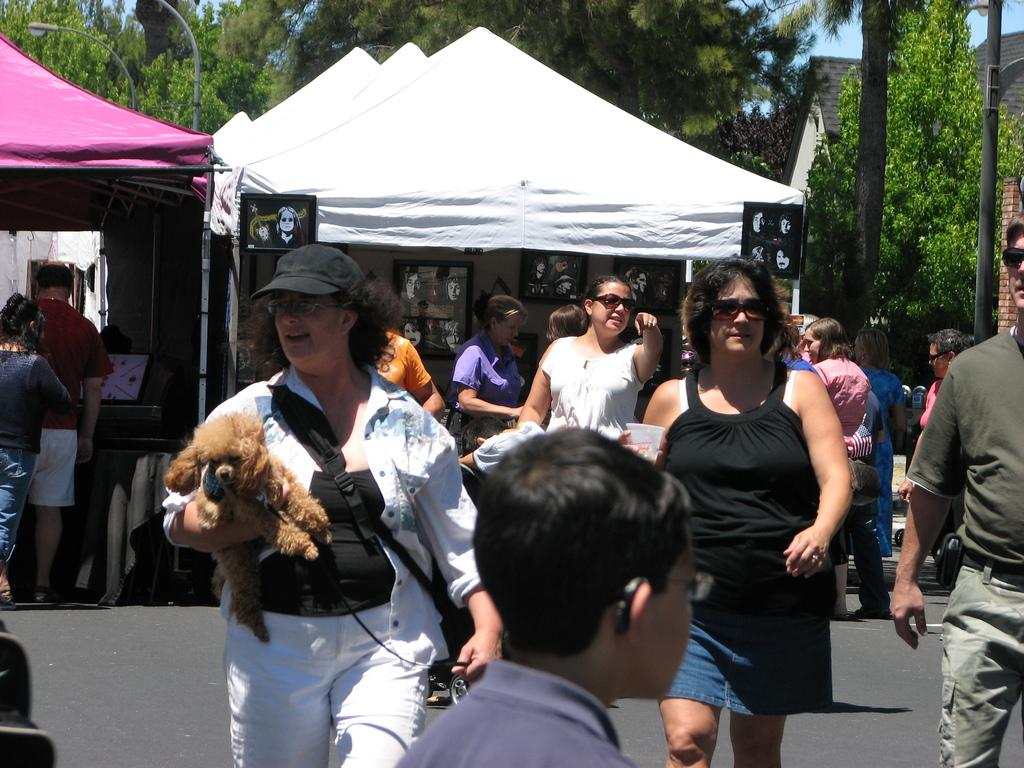What are the women in the image doing? The women in the image are walking. Can you describe the woman holding a dog and a bag? The woman holding a dog and a bag is wearing a black cap. What can be seen in the background of the image? In the background of the image, there are shops, trees, and houses. What is the maid saying good-bye to the woman with the dog and bag? There is no maid or good-bye in the image; it only shows women walking, one of whom is holding a dog and a bag. What type of coat is the woman wearing? The woman is not wearing a coat in the image; she is wearing a black cap. 